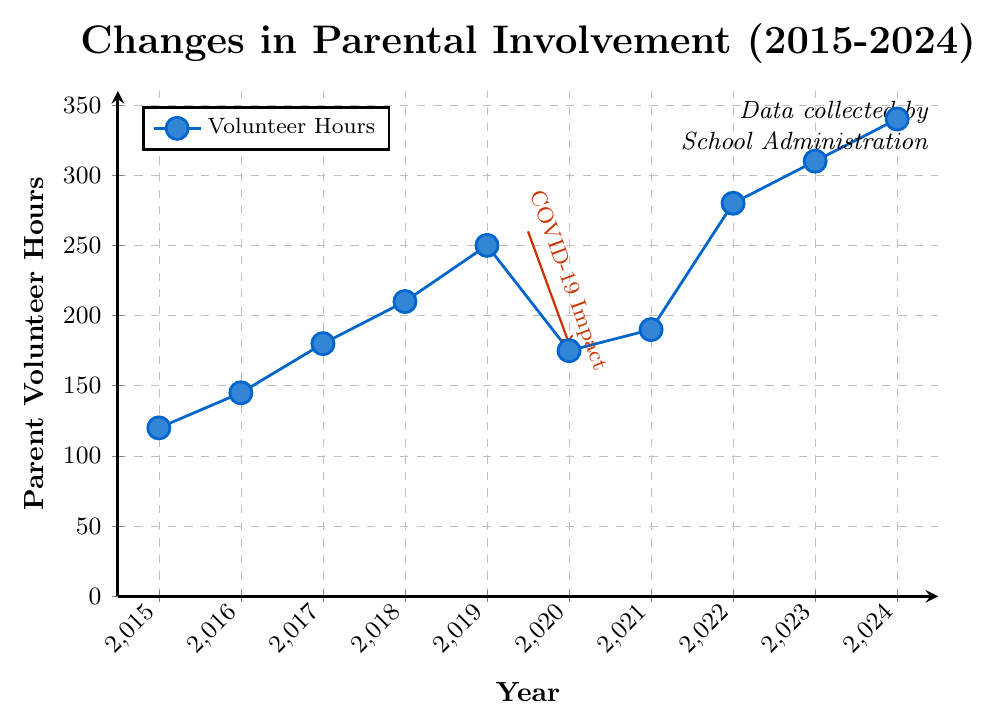What was the total number of volunteer hours over the entire period from 2015 to 2024? To find the total number of volunteer hours, we sum the values for each year: 120 (2015) + 145 (2016) + 180 (2017) + 210 (2018) + 250 (2019) + 175 (2020) + 190 (2021) + 280 (2022) + 310 (2023) + 340 (2024). The resulting sum is 2200 hours.
Answer: 2200 How much did parental volunteer hours increase from 2015 to 2019? To find the increase, we subtract the volunteer hours in 2015 from those in 2019: 250 (2019) - 120 (2015). The increase is 130 hours.
Answer: 130 During which year did parental involvement see the steepest decline? The steepest decline in parental involvement occurred between 2019 and 2020, where the volunteer hours dropped from 250 to 175. This decline is marked visually with a red arrow labeled “COVID-19 Impact”.
Answer: 2020 What is the average number of volunteer hours from 2016 to 2018? Sum the volunteer hours for 2016, 2017, and 2018: 145 (2016) + 180 (2017) + 210 (2018) = 535. Then, divide by the number of years (3): 535 / 3 = approximately 178.33 hours.
Answer: 178.33 Compare the number of volunteer hours in 2020 and 2021. Did it increase or decrease, and by how much? Volunteer hours in 2020 were 175, and in 2021 they were 190. To find the difference, subtract: 190 (2021) - 175 (2020) = 15. Therefore, the number of volunteer hours increased by 15 hours from 2020 to 2021.
Answer: Increased by 15 Which year had the highest number of volunteer hours, and what was the total? According to the data and the plot, the year with the highest volunteer hours is 2024, with a total of 340 hours.
Answer: 2024; 340 Calculate the median number of volunteer hours from 2015 to 2024. To find the median, we list the values in ascending order: 120, 145, 175, 180, 190, 210, 250, 280, 310, 340. The median is the average of the middle two values (190 and 210), so (190 + 210) / 2 = 200.
Answer: 200 Did any year experience no change in volunteer hours compared to the previous year? Examining the data, no consecutive years have the same number of volunteer hours; each year shows either an increase or decrease in volunteer hours compared to the previous year.
Answer: No How does the volunteer hour trend from 2015 to 2019 compare with the trend from 2020 to 2024? From 2015 to 2019, there is a steady increase in volunteer hours each year. From 2020 to 2024, there is a significant drop in 2020 but a strong increasing trend resumes from 2021 to 2024.
Answer: Steady increase (2015-2019), Dip in 2020 followed by increase (2020-2024) What is indicated by the red arrow and text on the plot? The red arrow and text indicate the impact of COVID-19, showing a significant drop in volunteer hours from 2019 to 2020.
Answer: COVID-19 Impact 